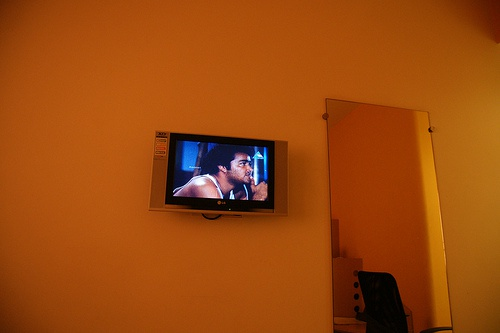Describe the objects in this image and their specific colors. I can see tv in maroon, black, and navy tones, people in maroon, black, brown, lightpink, and navy tones, and chair in maroon, black, and brown tones in this image. 